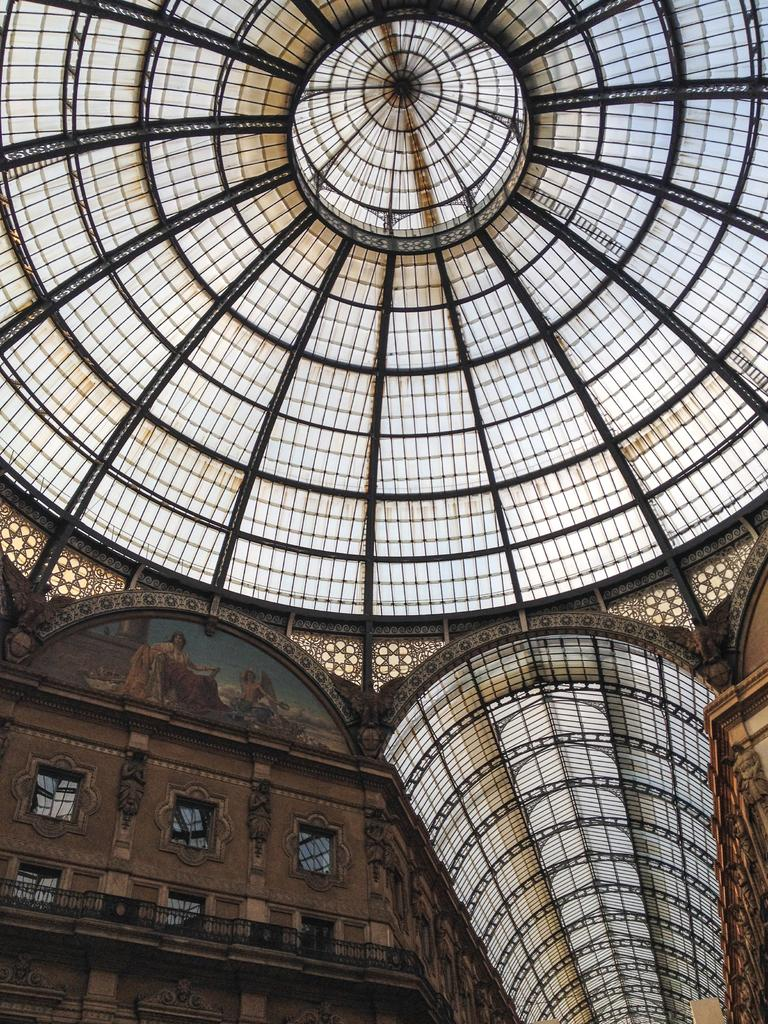What part of a building can be seen in the image? The image shows the roof of a building. What architectural feature can be seen on the building? There are windows visible on the building. What safety feature is present on the roof? The railing is present on the roof. What can be seen on the wall in the image? There are pictures on a wall in the image. What type of juice is being served in the image? There is no juice present in the image; it shows the roof of a building with windows, a railing, and pictures on a wall. 